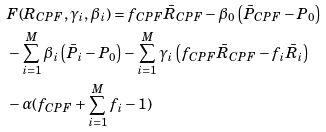Convert formula to latex. <formula><loc_0><loc_0><loc_500><loc_500>& F ( R _ { C P F } , \gamma _ { i } , \beta _ { i } ) = f _ { C P F } \bar { R } _ { C P F } - \beta _ { 0 } \left ( \bar { P } _ { C P F } - P _ { 0 } \right ) \\ & - \sum _ { i = 1 } ^ { M } \beta _ { i } \left ( \bar { P } _ { i } - P _ { 0 } \right ) - \sum _ { i = 1 } ^ { M } \gamma _ { i } \left ( f _ { C P F } \bar { R } _ { C P F } - f _ { i } \bar { R } _ { i } \right ) \\ & - \alpha ( f _ { C P F } + \sum _ { i = 1 } ^ { M } f _ { i } - 1 )</formula> 